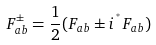Convert formula to latex. <formula><loc_0><loc_0><loc_500><loc_500>F _ { a b } ^ { \pm } = { \frac { 1 } { 2 } } ( F _ { a b } \pm i \, { ^ { ^ { * } } F _ { a b } } )</formula> 